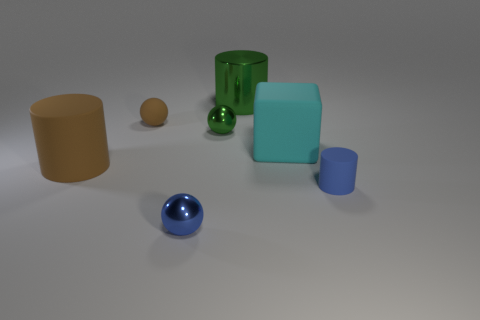Is the color of the small shiny thing that is in front of the tiny green metallic thing the same as the metallic cylinder?
Your answer should be very brief. No. What is the object that is to the right of the metallic cylinder and left of the tiny matte cylinder made of?
Offer a terse response. Rubber. The cyan matte block is what size?
Your answer should be very brief. Large. Do the big matte block and the rubber object behind the cube have the same color?
Offer a very short reply. No. How many other objects are the same color as the big matte cylinder?
Your answer should be very brief. 1. Does the shiny sphere behind the tiny blue rubber thing have the same size as the blue thing that is on the right side of the blue metal object?
Your answer should be compact. Yes. What is the color of the rubber cylinder behind the blue matte object?
Ensure brevity in your answer.  Brown. Are there fewer large shiny objects in front of the cyan rubber object than big cyan metallic cubes?
Your answer should be very brief. No. Is the block made of the same material as the tiny blue cylinder?
Your answer should be compact. Yes. There is a green shiny thing that is the same shape as the small blue matte object; what size is it?
Provide a short and direct response. Large. 